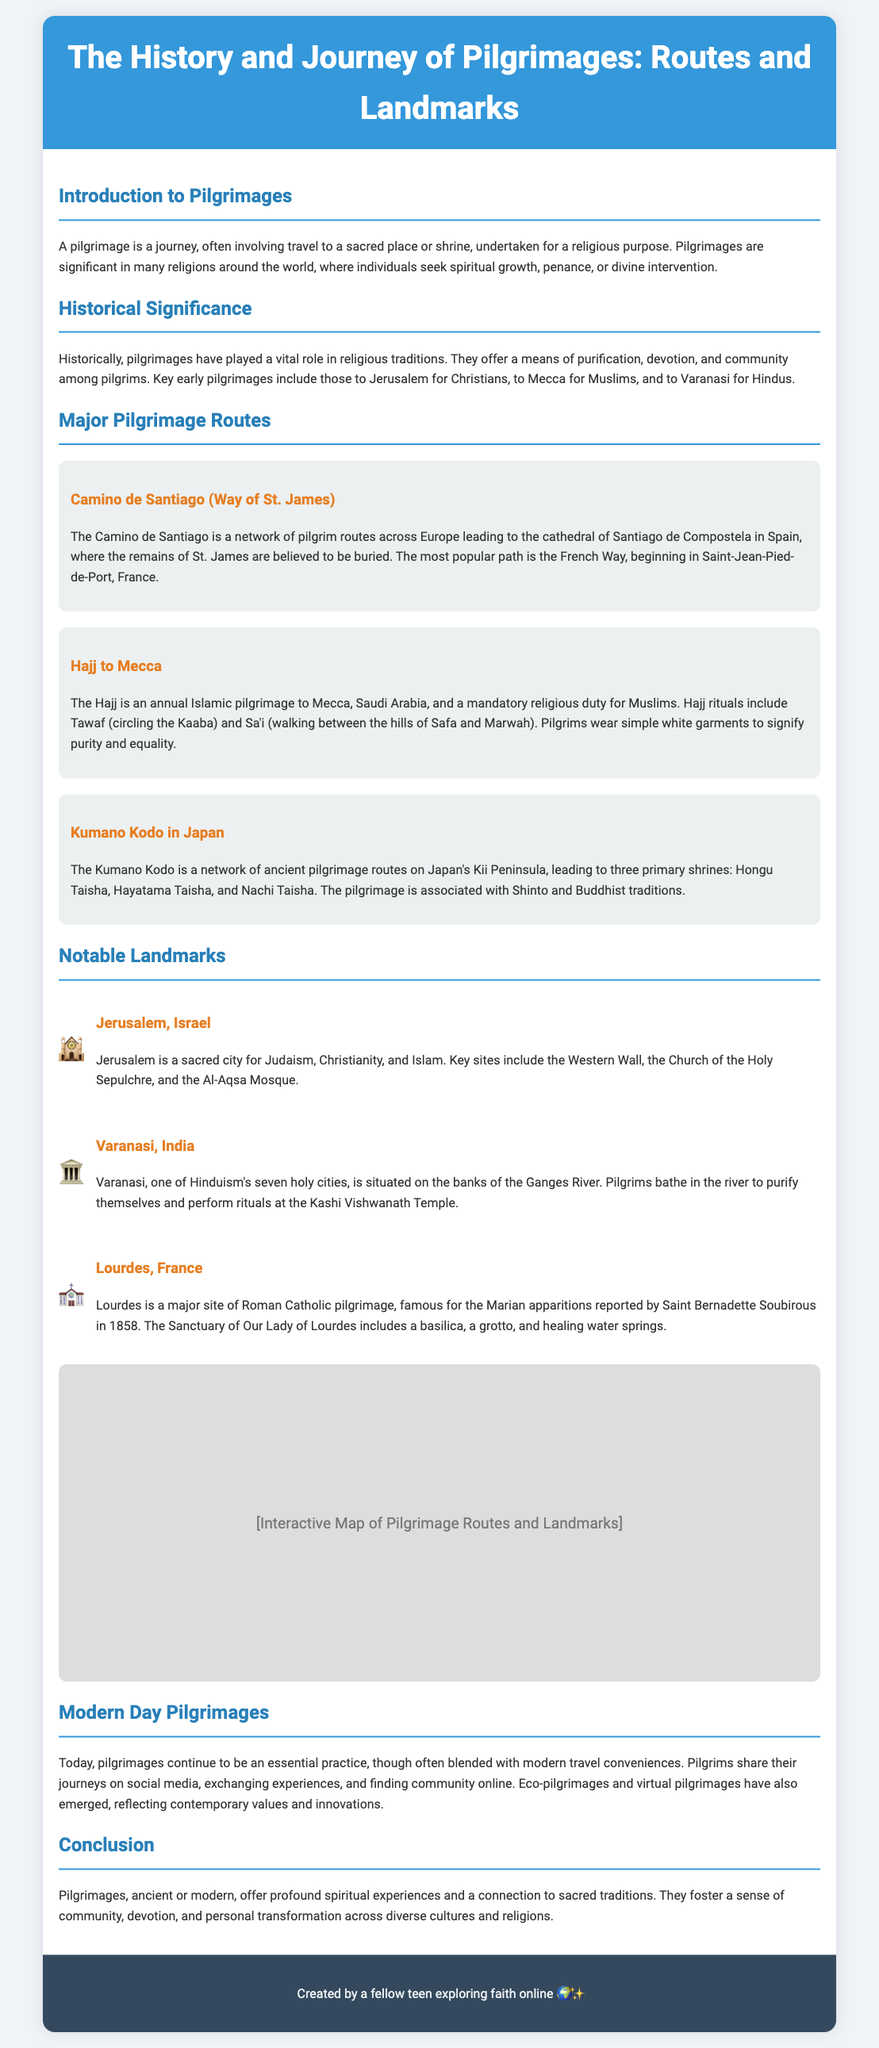What is the pilgrimage to Mecca called? The document mentions that the pilgrimage to Mecca is referred to as Hajj.
Answer: Hajj Which route leads to Santiago de Compostela? According to the document, the route leading to Santiago de Compostela is Camino de Santiago.
Answer: Camino de Santiago What city is considered a sacred site for Judaism, Christianity, and Islam? The document identifies Jerusalem as a sacred city for these three religions.
Answer: Jerusalem How many primary shrines are in the Kumano Kodo pilgrimage? It is stated that the Kumano Kodo leads to three primary shrines.
Answer: Three What is the significance of Varanasi in Hinduism? The document highlights that Varanasi is one of Hinduism's seven holy cities.
Answer: One of seven holy cities What do pilgrims wear during the Hajj? It is mentioned that pilgrims wear simple white garments during the Hajj to signify purity and equality.
Answer: Simple white garments What type of modern pilgrimage reflects contemporary values? The document discusses eco-pilgrimages as a type that reflects contemporary values.
Answer: Eco-pilgrimages What year did Saint Bernadette report the Marian apparitions in Lourdes? According to the document, the year reported by Saint Bernadette is 1858.
Answer: 1858 